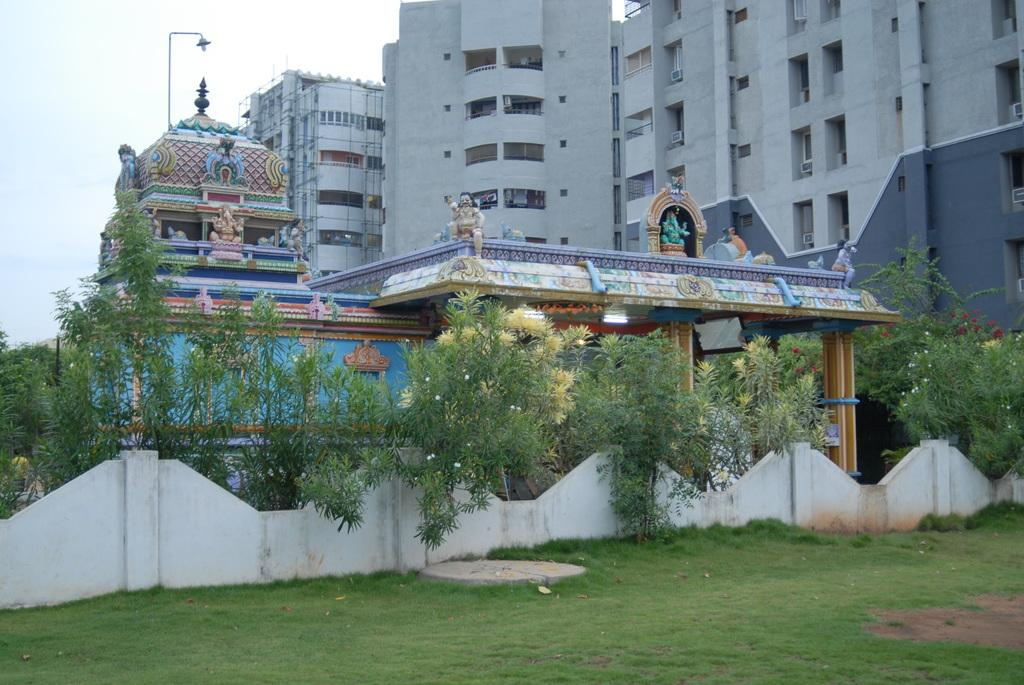What is the main structure in the center of the image? There is a temple in the center of the image. What type of vegetation can be seen in the image? There are plants in the image. What type of ground is visible at the bottom of the image? There is grass at the bottom of the image. What can be seen in the distance behind the temple? There are buildings in the background of the image. How many girls are sitting on the elbow of the stone statue in the image? There are no girls or stone statues present in the image. 